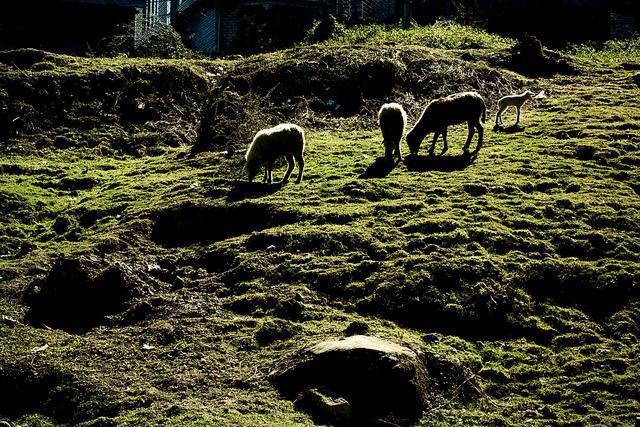How many babies in this picture?
Give a very brief answer. 1. How many sheep can be seen?
Give a very brief answer. 2. 